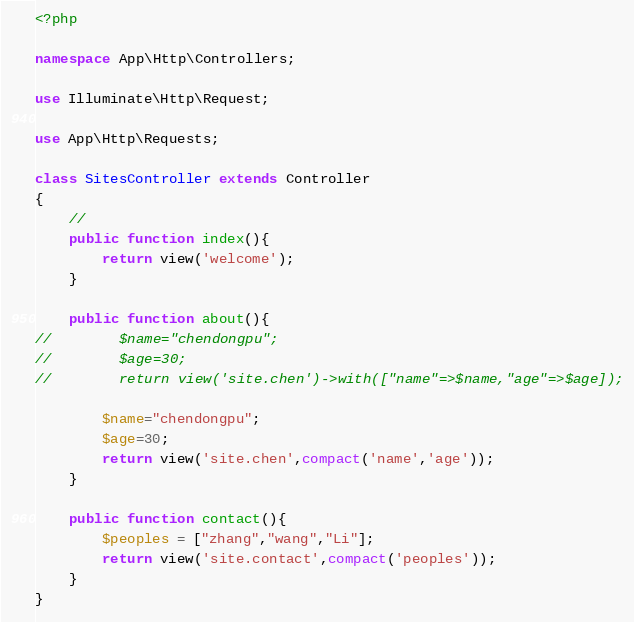Convert code to text. <code><loc_0><loc_0><loc_500><loc_500><_PHP_><?php

namespace App\Http\Controllers;

use Illuminate\Http\Request;

use App\Http\Requests;

class SitesController extends Controller
{
    //
    public function index(){
        return view('welcome');
    }

    public function about(){
//        $name="chendongpu";
//        $age=30;
//        return view('site.chen')->with(["name"=>$name,"age"=>$age]);

        $name="chendongpu";
        $age=30;
        return view('site.chen',compact('name','age'));
    }

    public function contact(){
        $peoples = ["zhang","wang","Li"];
        return view('site.contact',compact('peoples'));
    }
}
</code> 